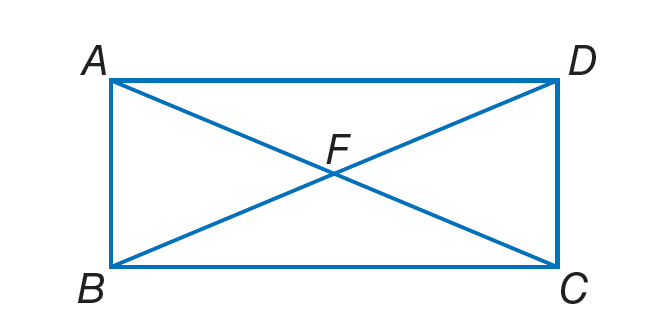Question: Quadrilateral A B C D is a rectangle. If m \angle A D B = 4 x + 8 and m \angle D B A = 6 x + 12, find x.
Choices:
A. 7
B. 20
C. 36
D. 54
Answer with the letter. Answer: A 